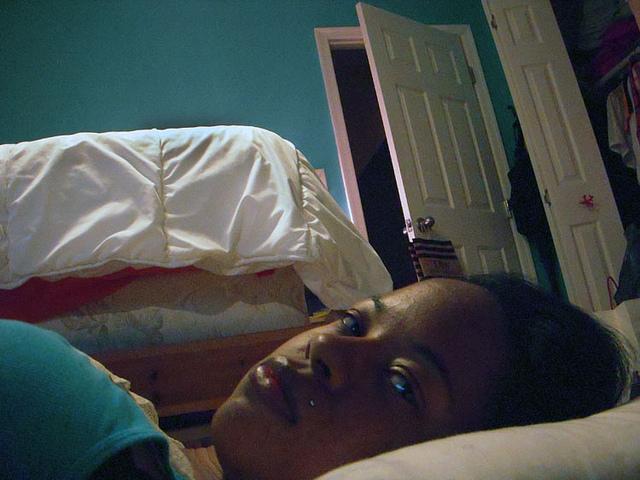How many doors are open?
Give a very brief answer. 2. How many cats are there?
Give a very brief answer. 0. How many beds are in the picture?
Give a very brief answer. 2. 